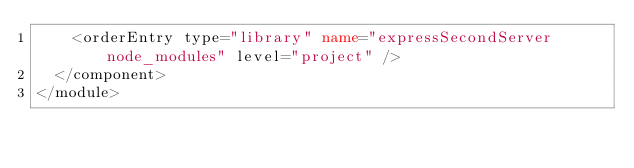Convert code to text. <code><loc_0><loc_0><loc_500><loc_500><_XML_>    <orderEntry type="library" name="expressSecondServer node_modules" level="project" />
  </component>
</module></code> 